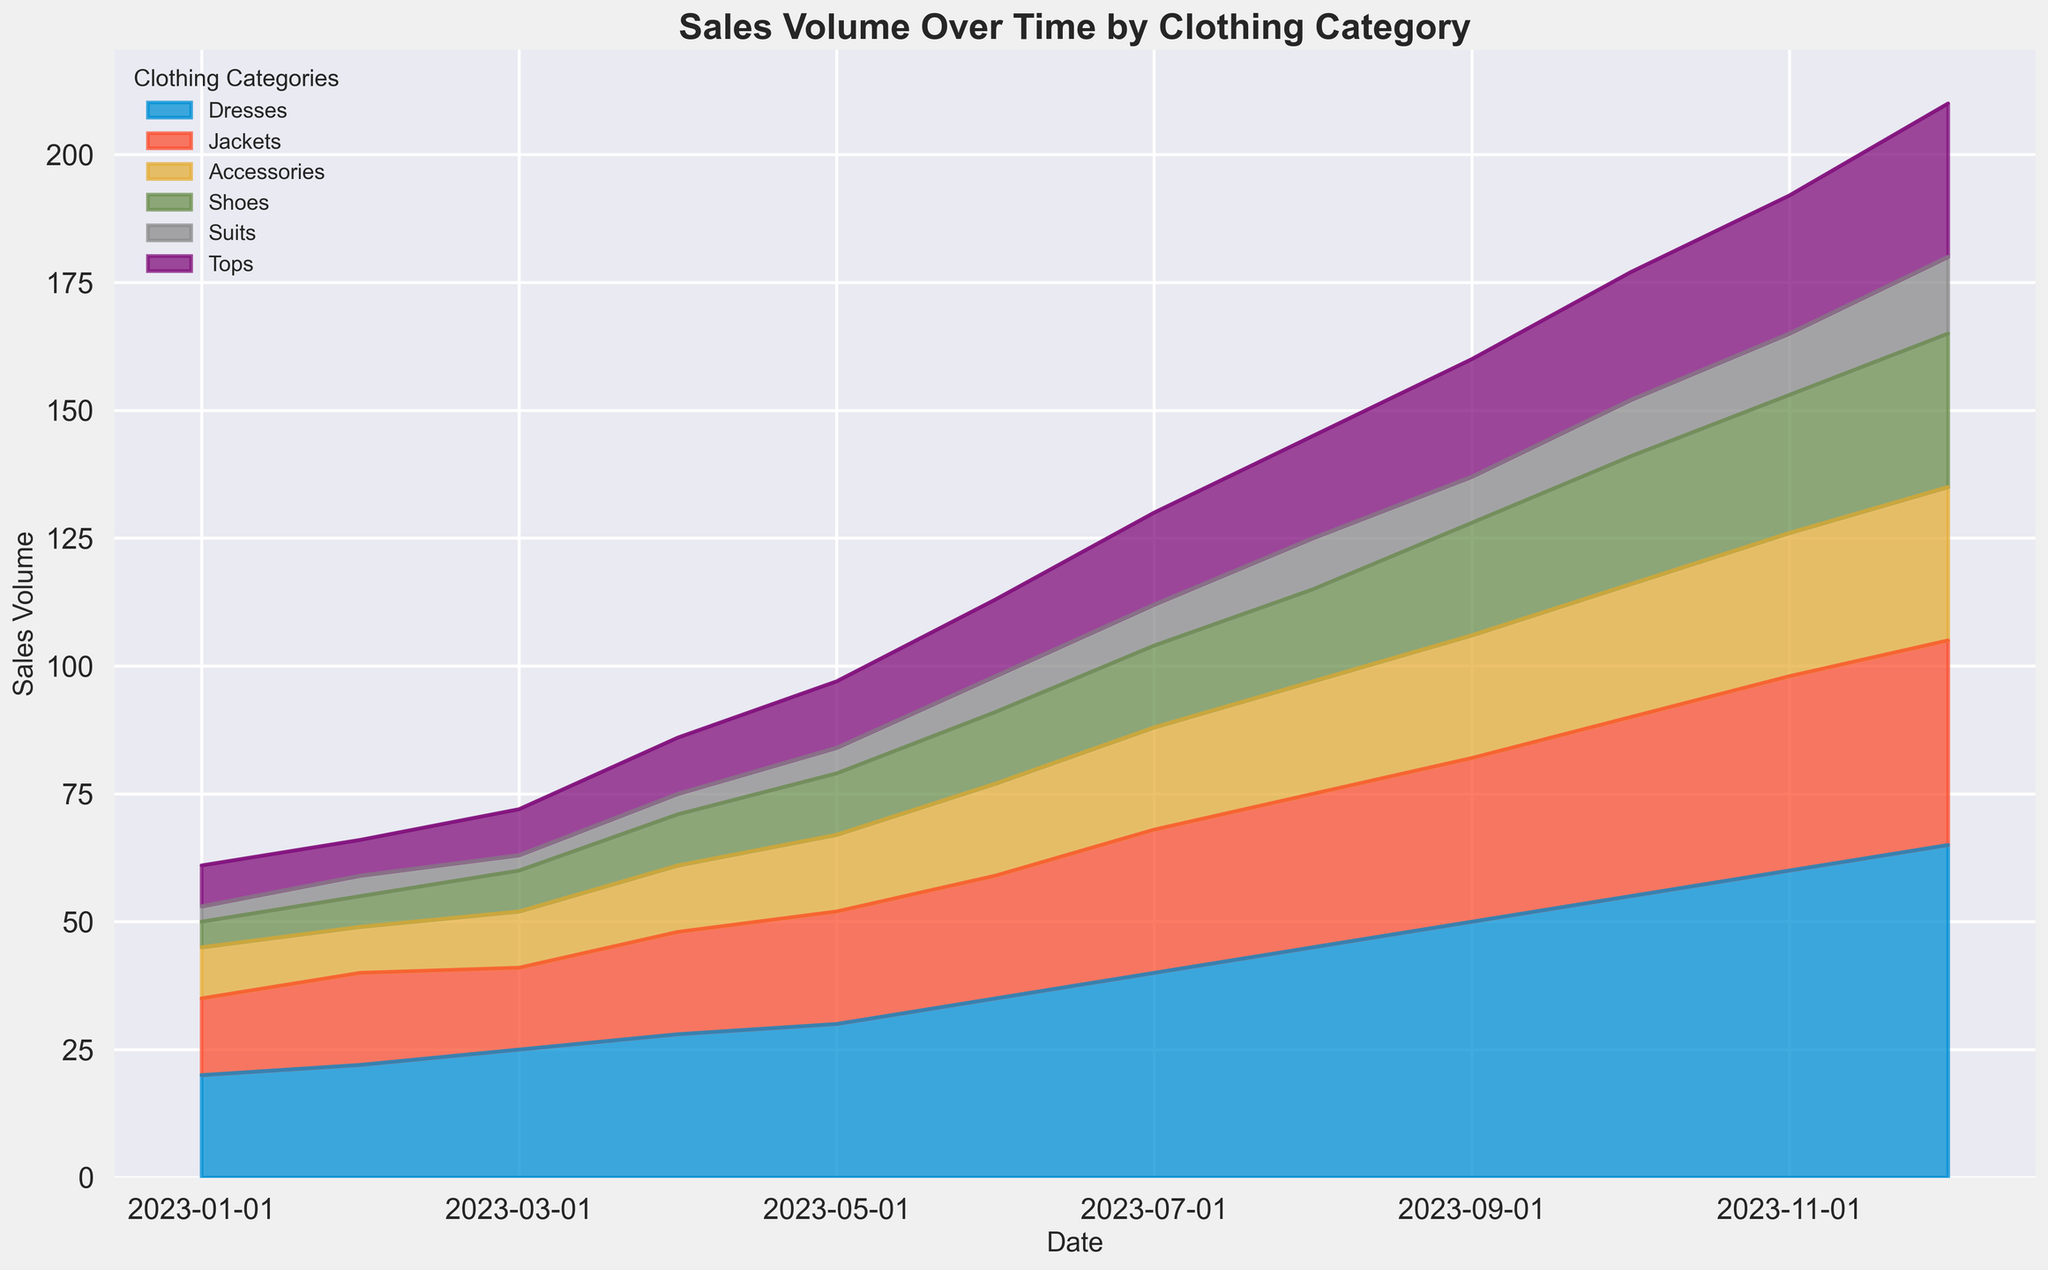Which clothing category showed the highest sales volume in December 2023? By observing the area chart, identify the category with the largest area at the end of December 2023.
Answer: Dresses Which month saw the highest increase in sales volume for Shoes compared to the previous month? Examine the area for Shoes across different months to find the month with the steepest increase. For instance, compare the area of Shoes in December to November, and so on.
Answer: October to November Between April 2023 and October 2023, which clothing category experienced the least growth in sales volume? Calculate the difference in sales volumes for each category in April and October. Identify the category with the smallest difference.
Answer: Suits What is the combined sales volume of Dresses and Jackets in July 2023? Sum the sales volumes for Dresses and Jackets for July 2023: Dresses (40) + Jackets (28) = 68
Answer: 68 Which clothing category had a consistent increase in sales volume every month throughout the year? Check the sales volume for each category month by month to see if there is a consistent increase.
Answer: Dresses In which month did Accessories surpass Shoes in total sales volume for the first time? Compare the sales volumes of Accessories and Shoes month by month to find the first instance where Accessories exceed Shoes.
Answer: May 2023 How much higher were the sales volumes of Tops in December 2023 compared to January 2023? Subtract the sales volume of Tops in January 2023 from that in December 2023 (30 - 8 = 22).
Answer: 22 Which two clothing categories had the closest sales volumes in February 2023? Compare the sales volumes for each category in February 2023 and find the two with the smallest difference.
Answer: Accessories and Tops What is the visual trend of Suits' sales volume over the year? Observe the trend in the area representing Suits. Note if it shows a rising, falling, or constant pattern over the months.
Answer: Gradually increasing By how much did the total sales volume increase from January 2023 to December 2023? Calculate the total sales volume in January 2023 and December 2023 and find the difference (20+15+10+5+3+8 = 61 and 65+40+30+30+15+30 = 210). The increase is 210 - 61 = 149.
Answer: 149 